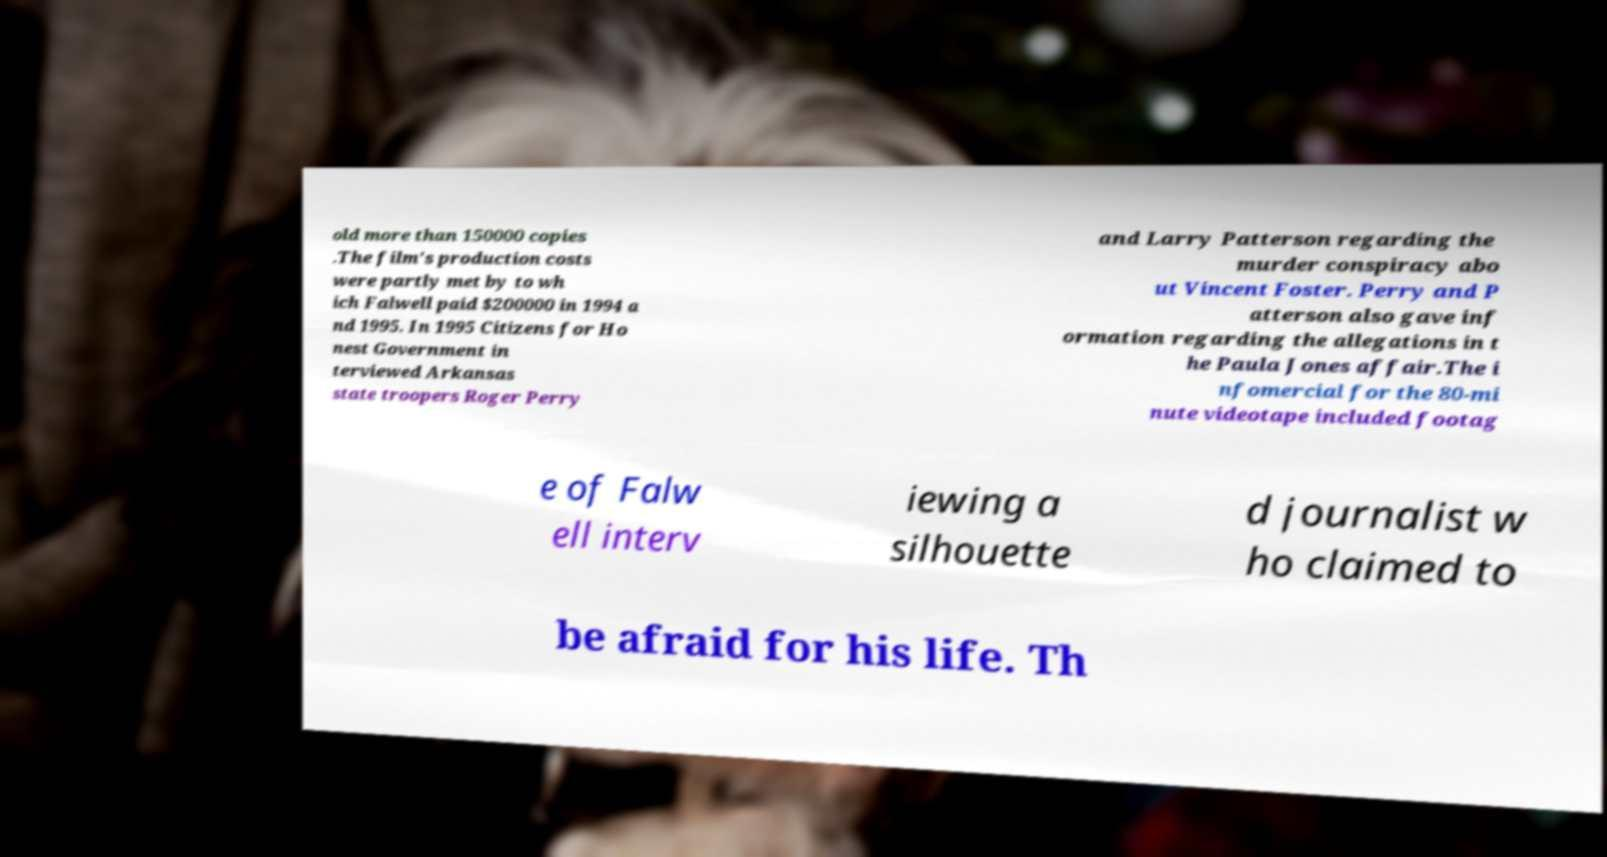Could you extract and type out the text from this image? old more than 150000 copies .The film's production costs were partly met by to wh ich Falwell paid $200000 in 1994 a nd 1995. In 1995 Citizens for Ho nest Government in terviewed Arkansas state troopers Roger Perry and Larry Patterson regarding the murder conspiracy abo ut Vincent Foster. Perry and P atterson also gave inf ormation regarding the allegations in t he Paula Jones affair.The i nfomercial for the 80-mi nute videotape included footag e of Falw ell interv iewing a silhouette d journalist w ho claimed to be afraid for his life. Th 